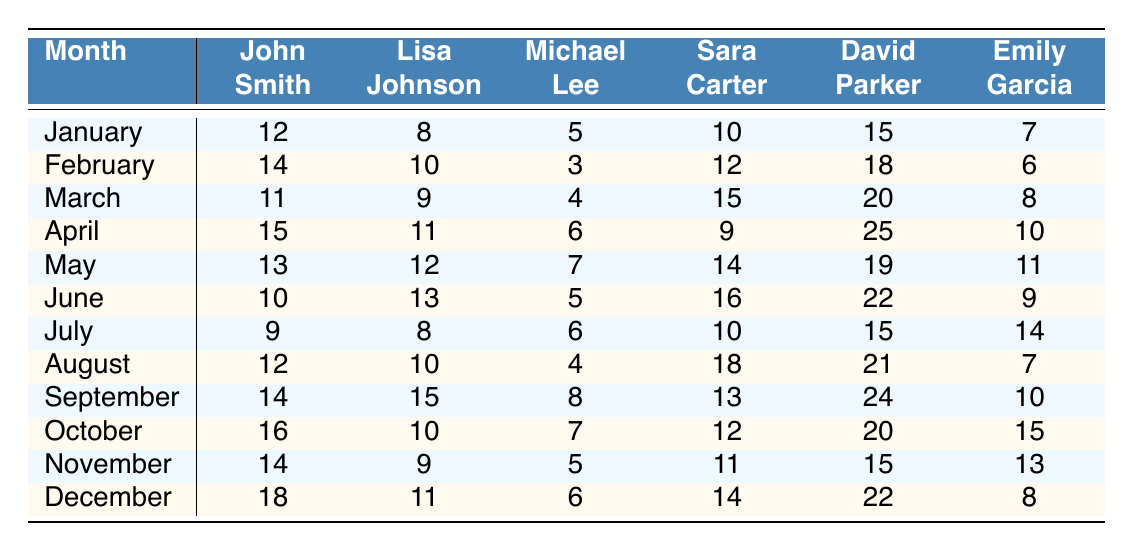What is the total number of volunteer hours contributed by Sara Carter in January? In January, Sara Carter contributed 10 volunteer hours. Checking the table, this value is clearly indicated under the January row, in Sara Carter's column.
Answer: 10 Which month did David Parker contribute the most volunteer hours? Looking through the table, David Parker contributed 25 hours in April, which is the highest value when compared to the hours for other months listed for him.
Answer: April How many volunteer hours did Lisa Johnson contribute in June compared to August? In June, Lisa Johnson contributed 13 hours, while in August she contributed 10 hours. Thus, comparing the two shows that she contributed 3 more hours in June than in August.
Answer: 3 What is the average number of volunteer hours contributed by John Smith throughout the year? Adding up John Smith's hours from each month: 12 + 14 + 11 + 15 + 13 + 10 + 9 + 12 + 14 + 16 + 14 + 18 =  166. Since there are 12 months, the average is 166 / 12 = approximately 13.83.
Answer: Approximately 13.83 Did Emily Garcia contribute more hours than Michael Lee in September? In September, Emily Garcia contributed 10 hours and Michael Lee contributed 8 hours. Since 10 is greater than 8, Emily indeed contributed more.
Answer: Yes What is the total volunteer hours contributed by all members in December? Summing up the contributions in December: 18 (John) + 11 (Lisa) + 6 (Michael) + 14 (Sara) + 22 (David) + 8 (Emily) = 79. Thus, the total for December is 79.
Answer: 79 In which month did Michael Lee contribute the least volunteer hours, and how many were they? The least number of hours from Michael Lee is 3, which he contributed in February. This information can be confirmed by locating the minimum value under his column.
Answer: February, 3 Calculate the difference in volunteer hours contributed by David Parker between April and June. In April, David Parker contributed 25 hours, while in June he contributed 22 hours. The difference is 25 - 22 = 3 hours, indicating that he contributed 3 more hours in April than in June.
Answer: 3 Which member contributed the highest number of volunteer hours in March, and how many were there? In March, David Parker contributed 20 hours, which is the highest compared to the other members’ hours for that month.
Answer: David Parker, 20 How many more hours did Sara Carter contribute in January than in November? In January, Sara Carter contributed 10 hours, while in November she contributed 11 hours. The difference is 10 - 11 = -1, meaning she contributed 1 hour less in January compared to November.
Answer: 1 less in January What is the median contribution for Lisa Johnson across all months? The contributions for Lisa Johnson are: 8, 10, 9, 11, 12, 13, 8, 10, 15, 10, 9, 11. Sorting these gives 8, 8, 9, 9, 10, 10, 10, 11, 11, 12, 13, 15. The median of the sorted list (the average of the 6th and 7th values) is (10 + 10) / 2 = 10.
Answer: 10 